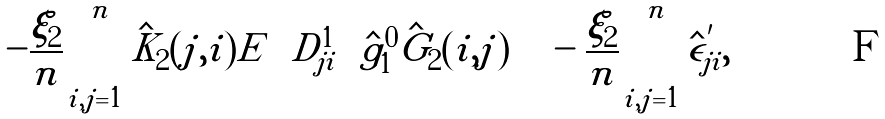<formula> <loc_0><loc_0><loc_500><loc_500>- \frac { \xi _ { 2 } } { n } \sum _ { i , j = 1 } ^ { n } \hat { K } _ { 2 } ( j , i ) { E } \left \{ D ^ { 1 } _ { j i } \left ( \hat { g } ^ { 0 } _ { 1 } \hat { G } _ { 2 } ( i , j ) \right ) \right \} - \frac { \xi _ { 2 } } { n } \sum _ { i , j = 1 } ^ { n } \hat { \epsilon } ^ { ^ { \prime } } _ { j i } ,</formula> 